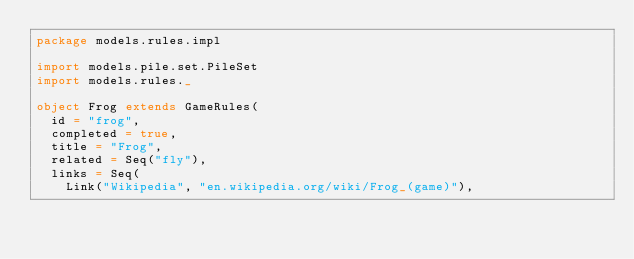<code> <loc_0><loc_0><loc_500><loc_500><_Scala_>package models.rules.impl

import models.pile.set.PileSet
import models.rules._

object Frog extends GameRules(
  id = "frog",
  completed = true,
  title = "Frog",
  related = Seq("fly"),
  links = Seq(
    Link("Wikipedia", "en.wikipedia.org/wiki/Frog_(game)"),</code> 